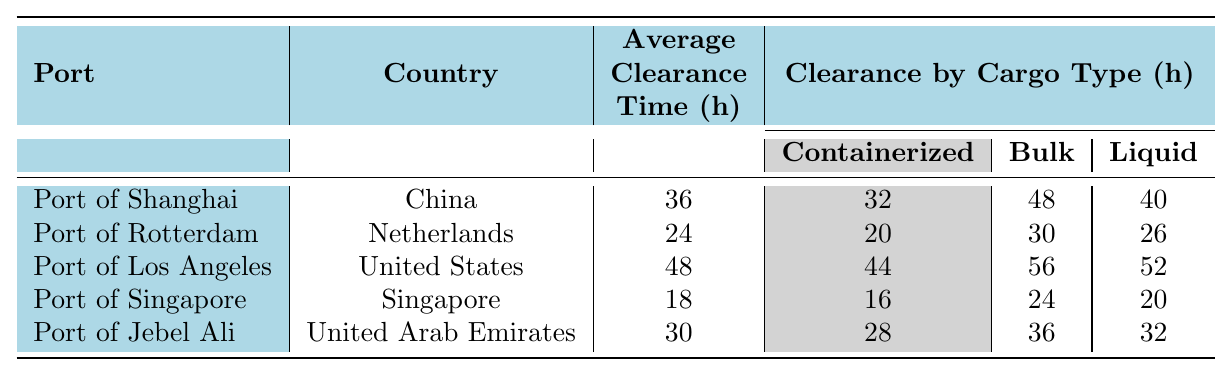What is the average clearance time for the Port of Rotterdam? The table specifies the average clearance time as 24 hours for the Port of Rotterdam.
Answer: 24 hours Which port has the longest average clearance time? By comparing the average clearance times listed, the Port of Los Angeles has the longest average clearance time at 48 hours.
Answer: Port of Los Angeles How does the average clearance time of Port of Singapore compare to that of Port of Shanghai? The average clearance time for Port of Singapore is 18 hours, while for Port of Shanghai it is 36 hours. The difference is 36 - 18 = 18 hours, indicating Port of Singapore has a faster clearance time by 18 hours.
Answer: Port of Singapore is faster by 18 hours What is the average clearance time for containerized cargo at the Port of Jebel Ali? The clearance time for containerized cargo at the Port of Jebel Ali is listed as 28 hours in the table.
Answer: 28 hours Which port has the lowest average clearance time, and how much lower is it compared to the highest? The Port of Singapore has the lowest average clearance time at 18 hours. The highest is the Port of Los Angeles at 48 hours. The difference is 48 - 18 = 30 hours, making Port of Singapore 30 hours lower.
Answer: Port of Singapore is lower by 30 hours What factors affect clearance at the Port of Shanghai? The table lists factors affecting clearance at the Port of Shanghai as documentation complexity, inspection rate, and port congestion.
Answer: Documentation complexity, inspection rate, port congestion Is the average clearance time at the Port of Rotterdam less than the average clearance time at the Port of Los Angeles? The average clearance time at the Port of Rotterdam is 24 hours, while at the Port of Los Angeles it is 48 hours. Since 24 is less than 48, it is true.
Answer: Yes What is the total clearance time for bulk cargo across all ports? By summing the bulk cargo clearance times from each port: 48 (Shanghai) + 30 (Rotterdam) + 56 (Los Angeles) + 24 (Singapore) + 36 (Jebel Ali) = 194 hours total for bulk cargo clearance across all ports.
Answer: 194 hours Which port has a higher clearance time for liquid cargo: Port of Shanghai or Port of Singapore? The clearance time for liquid cargo at the Port of Shanghai is 40 hours and at Port of Singapore is 20 hours. Since 40 is greater than 20, the Port of Shanghai has a higher clearance time for liquid cargo.
Answer: Port of Shanghai Calculate the average clearance time for all ports listed. The average is calculated by summing all average clearance times: (36 + 24 + 48 + 18 + 30) = 156 hours, then dividing by the number of ports (5), which equals 156 / 5 = 31.2 hours.
Answer: 31.2 hours 